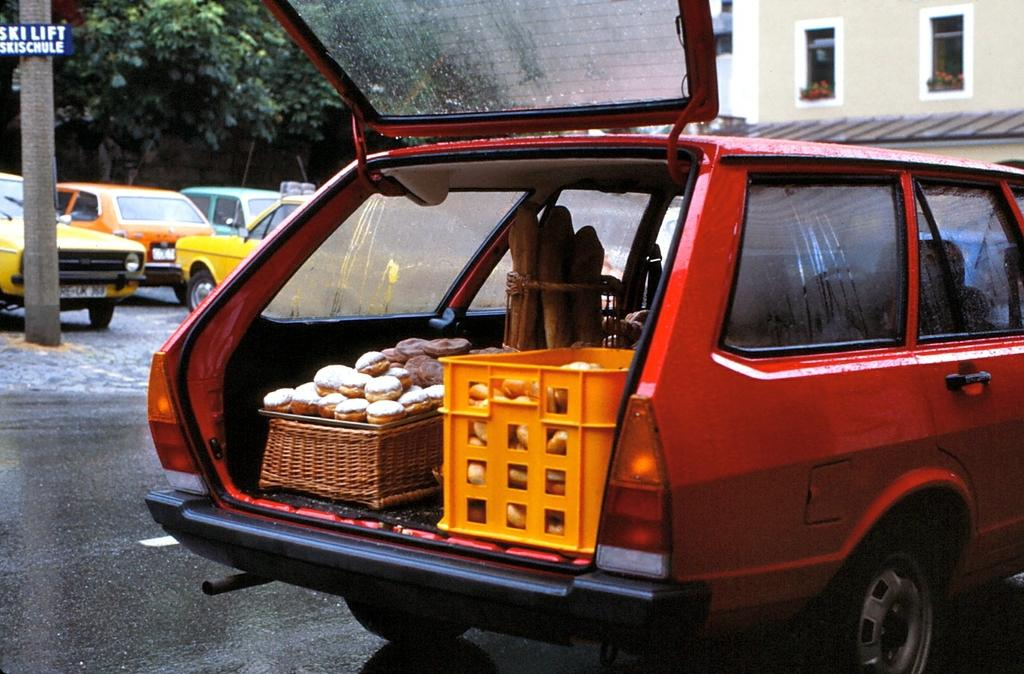<image>
Present a compact description of the photo's key features. A car with its hatch open and in the background is a sign reading ski lift 